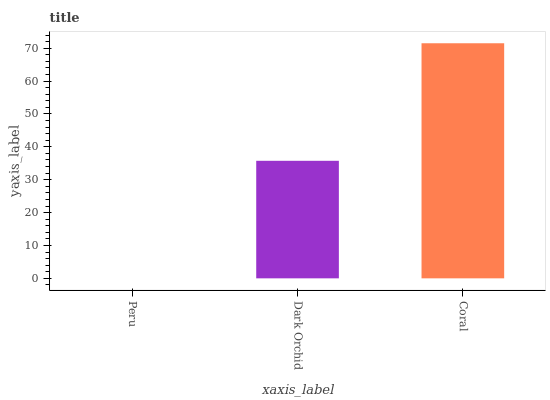Is Peru the minimum?
Answer yes or no. Yes. Is Coral the maximum?
Answer yes or no. Yes. Is Dark Orchid the minimum?
Answer yes or no. No. Is Dark Orchid the maximum?
Answer yes or no. No. Is Dark Orchid greater than Peru?
Answer yes or no. Yes. Is Peru less than Dark Orchid?
Answer yes or no. Yes. Is Peru greater than Dark Orchid?
Answer yes or no. No. Is Dark Orchid less than Peru?
Answer yes or no. No. Is Dark Orchid the high median?
Answer yes or no. Yes. Is Dark Orchid the low median?
Answer yes or no. Yes. Is Peru the high median?
Answer yes or no. No. Is Coral the low median?
Answer yes or no. No. 